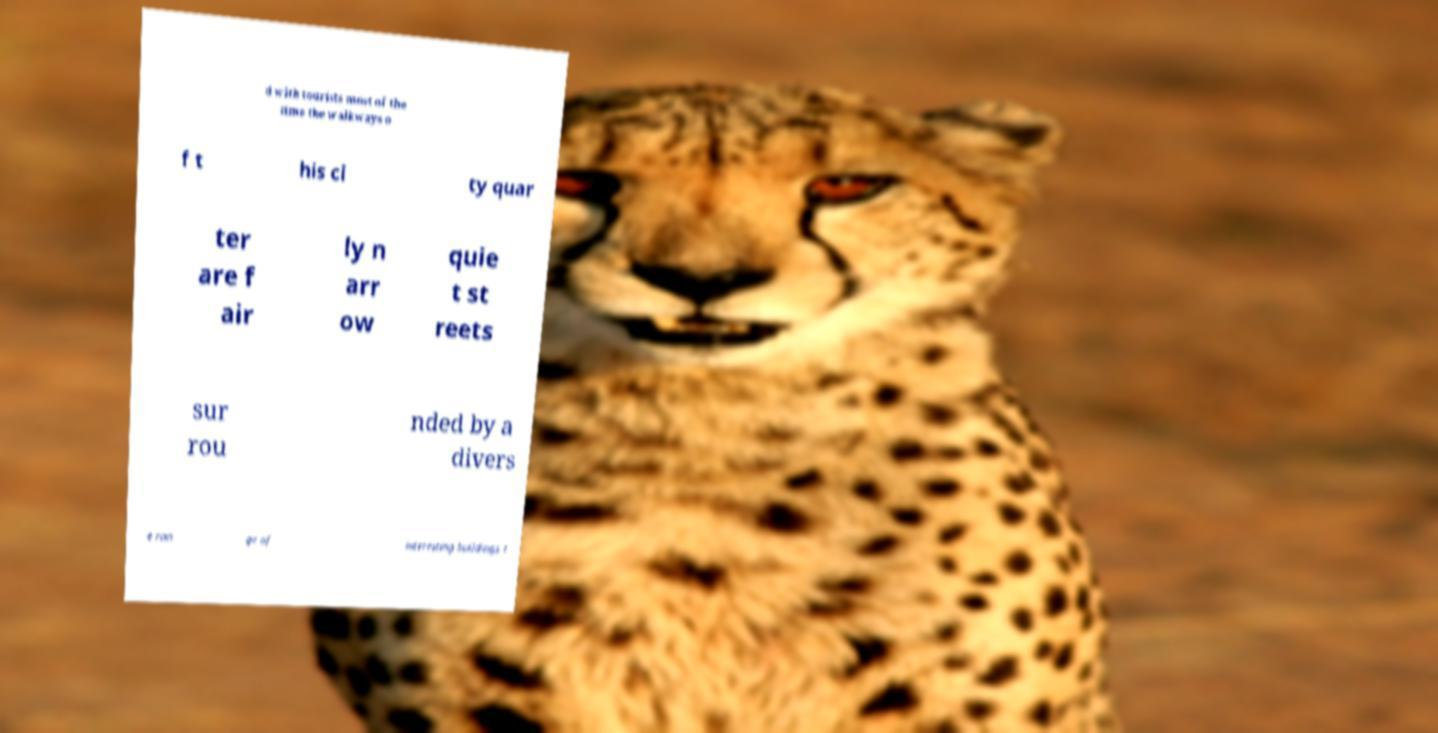I need the written content from this picture converted into text. Can you do that? d with tourists most of the time the walkways o f t his ci ty quar ter are f air ly n arr ow quie t st reets sur rou nded by a divers e ran ge of interesting buildings t 